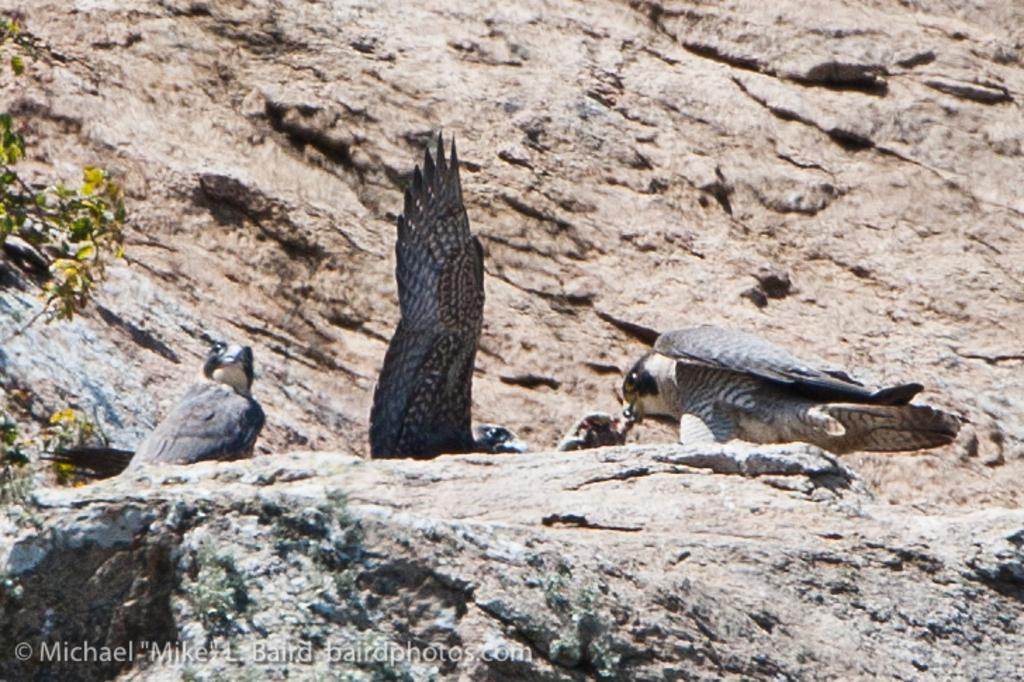What type of animals can be seen in the image? There are birds in the image. What other objects or elements can be seen in the image? There are rocks and leaves in the image. Is there any indication of the image's origin or ownership? Yes, there is a watermark on the image. What type of friction can be observed between the birds' toes and the rocks in the image? There is no information about the birds' toes or the friction between them and the rocks in the image. 